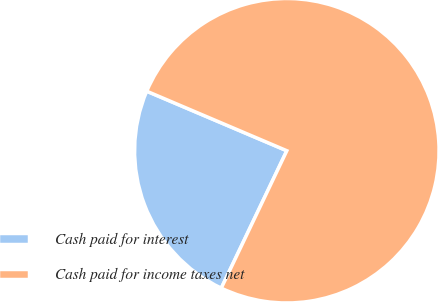Convert chart to OTSL. <chart><loc_0><loc_0><loc_500><loc_500><pie_chart><fcel>Cash paid for interest<fcel>Cash paid for income taxes net<nl><fcel>24.31%<fcel>75.69%<nl></chart> 